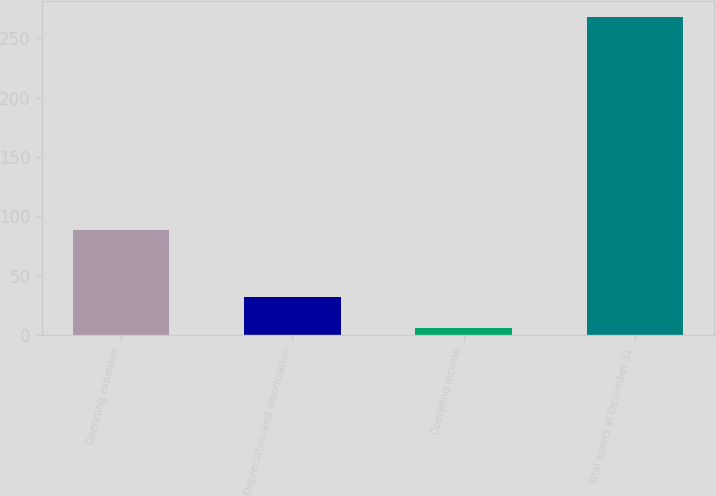Convert chart to OTSL. <chart><loc_0><loc_0><loc_500><loc_500><bar_chart><fcel>Operating expenses<fcel>Depreciation and amortization<fcel>Operating income<fcel>Total assets at December 31<nl><fcel>88.7<fcel>32.24<fcel>6<fcel>268.4<nl></chart> 